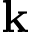Convert formula to latex. <formula><loc_0><loc_0><loc_500><loc_500>k</formula> 